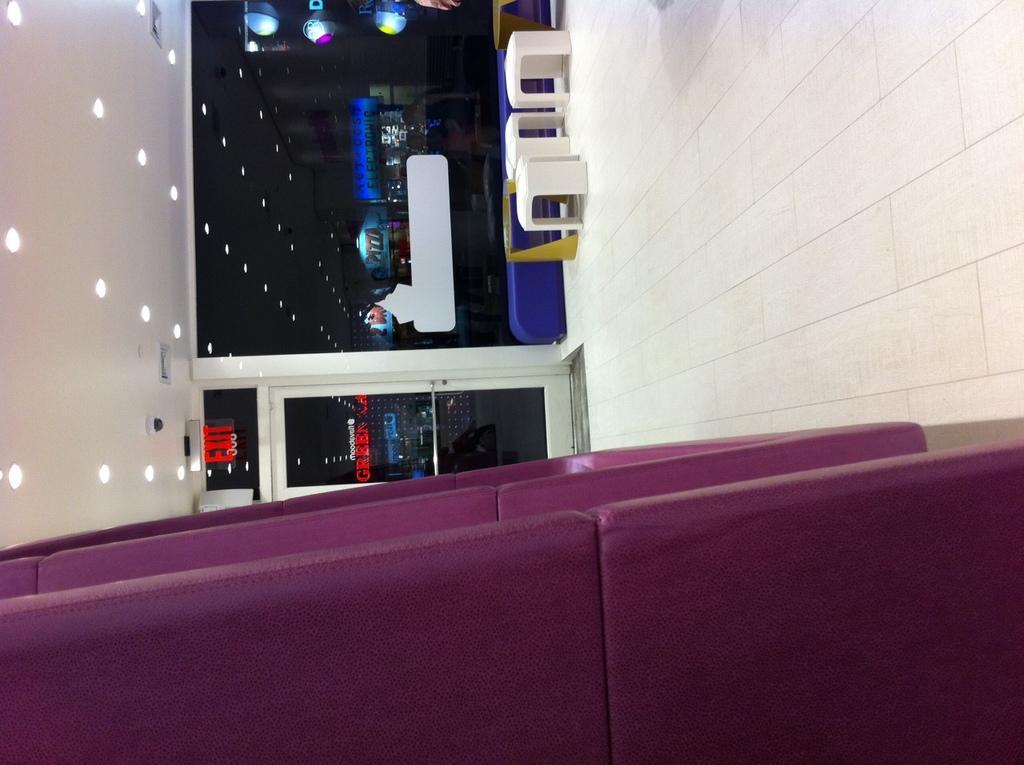In one or two sentences, can you explain what this image depicts? In this image I can see the pink color object. To the side I can see the white colored stools. In the background I can see the glass and the exit board. I can also see the lights in the top. 